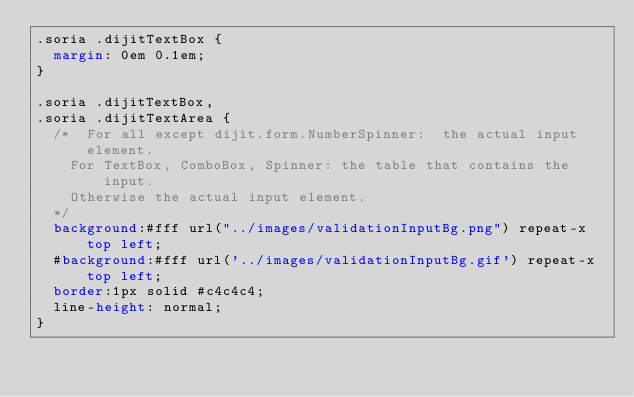Convert code to text. <code><loc_0><loc_0><loc_500><loc_500><_CSS_>.soria .dijitTextBox {
	margin: 0em 0.1em;
}

.soria .dijitTextBox,
.soria .dijitTextArea {
	/* 	For all except dijit.form.NumberSpinner:  the actual input element.
		For TextBox, ComboBox, Spinner: the table that contains the input.
		Otherwise the actual input element.
	*/
	background:#fff url("../images/validationInputBg.png") repeat-x top left;
	#background:#fff url('../images/validationInputBg.gif') repeat-x top left;
	border:1px solid #c4c4c4;
	line-height: normal;
}</code> 